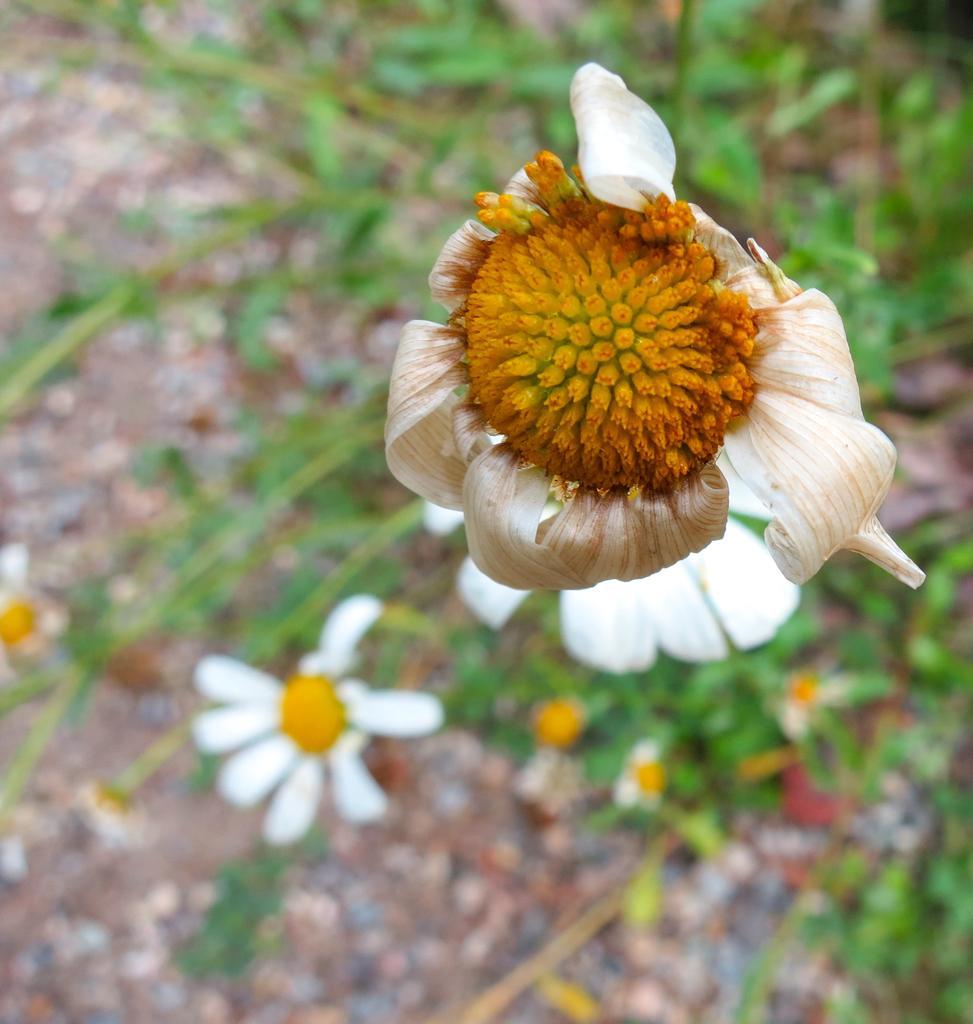In one or two sentences, can you explain what this image depicts? In the picture we can see some plants with two flowers with petals which are white in color and in the middle of the flower we can see yellow in color. 